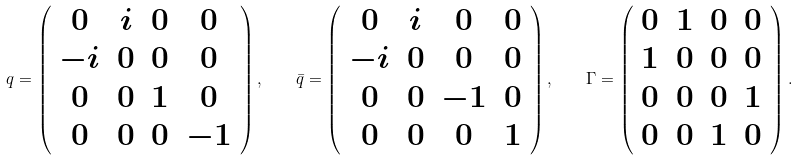Convert formula to latex. <formula><loc_0><loc_0><loc_500><loc_500>q = \left ( \begin{array} { c c c c } 0 & i & 0 & 0 \\ - i & 0 & 0 & 0 \\ 0 & 0 & 1 & 0 \\ 0 & 0 & 0 & - 1 \end{array} \right ) , \quad \bar { q } = \left ( \begin{array} { c c c c } 0 & i & 0 & 0 \\ - i & 0 & 0 & 0 \\ 0 & 0 & - 1 & 0 \\ 0 & 0 & 0 & 1 \end{array} \right ) , \quad \Gamma = \left ( \begin{array} { c c c c } 0 & 1 & 0 & 0 \\ 1 & 0 & 0 & 0 \\ 0 & 0 & 0 & 1 \\ 0 & 0 & 1 & 0 \end{array} \right ) .</formula> 